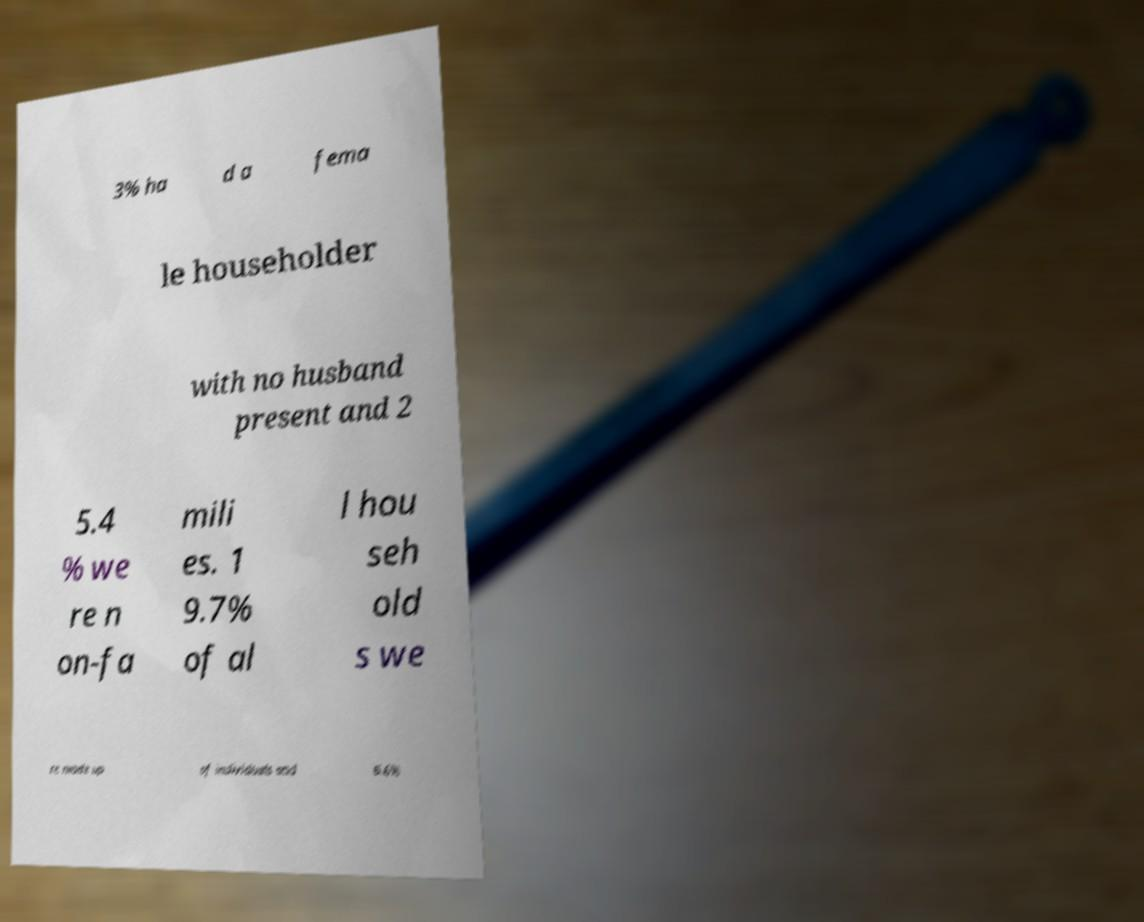Please identify and transcribe the text found in this image. 3% ha d a fema le householder with no husband present and 2 5.4 % we re n on-fa mili es. 1 9.7% of al l hou seh old s we re made up of individuals and 6.6% 